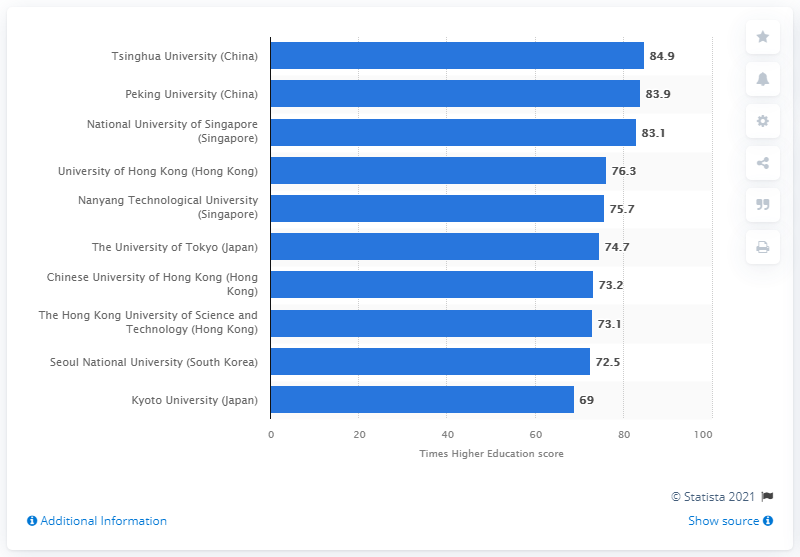Give some essential details in this illustration. In 2021, Tsinghua University achieved a score of 84.9. 